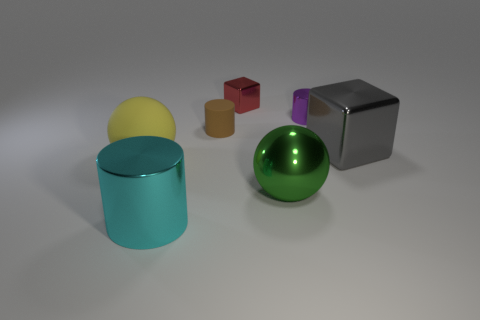Add 2 green things. How many objects exist? 9 Subtract all balls. How many objects are left? 5 Subtract 0 purple spheres. How many objects are left? 7 Subtract all small gray rubber cylinders. Subtract all cyan shiny things. How many objects are left? 6 Add 2 big green metallic things. How many big green metallic things are left? 3 Add 5 large shiny things. How many large shiny things exist? 8 